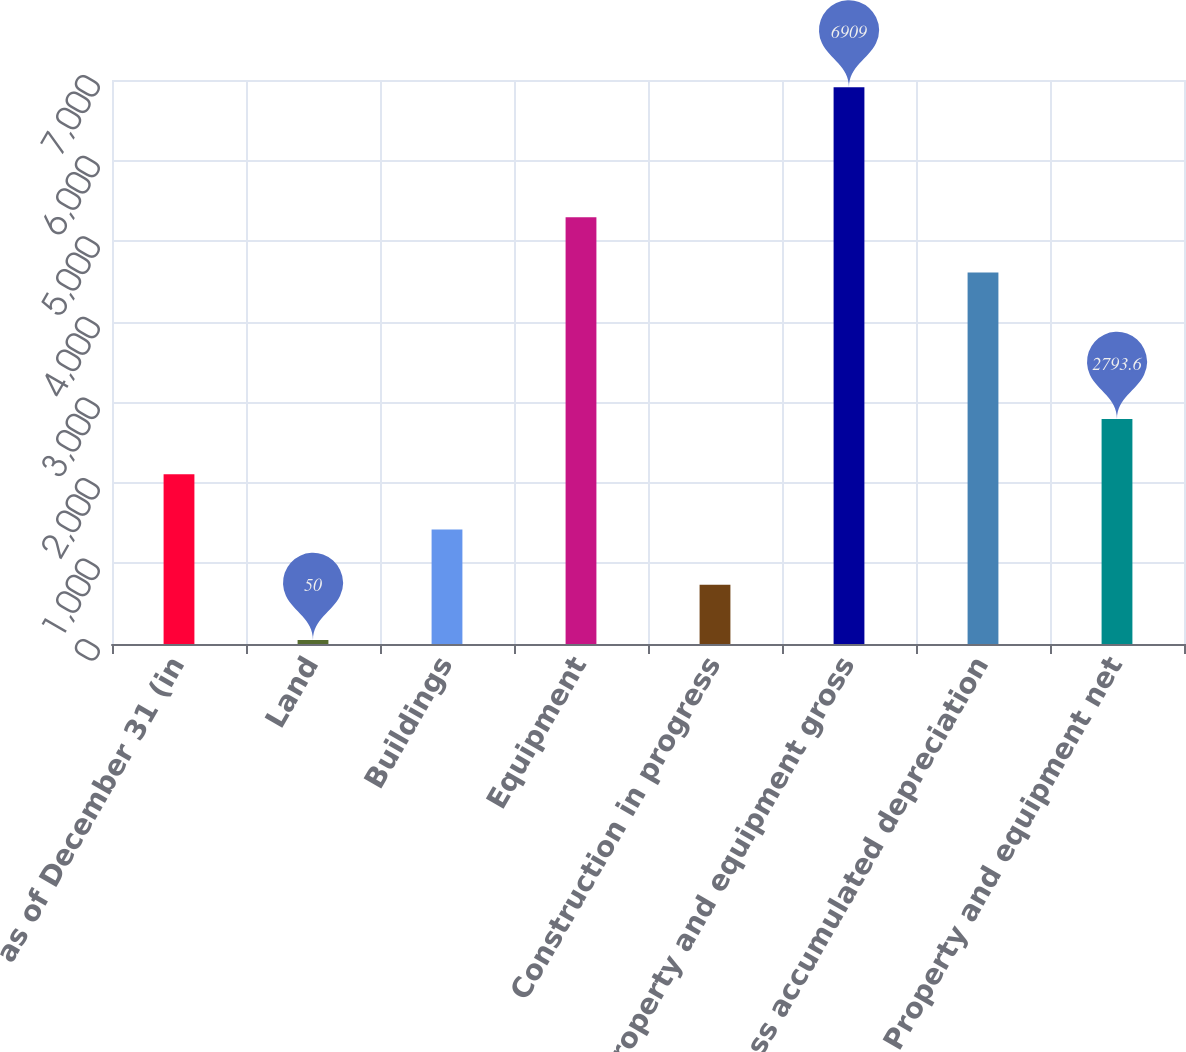Convert chart to OTSL. <chart><loc_0><loc_0><loc_500><loc_500><bar_chart><fcel>as of December 31 (in<fcel>Land<fcel>Buildings<fcel>Equipment<fcel>Construction in progress<fcel>Property and equipment gross<fcel>Less accumulated depreciation<fcel>Property and equipment net<nl><fcel>2107.7<fcel>50<fcel>1421.8<fcel>5296.9<fcel>735.9<fcel>6909<fcel>4611<fcel>2793.6<nl></chart> 